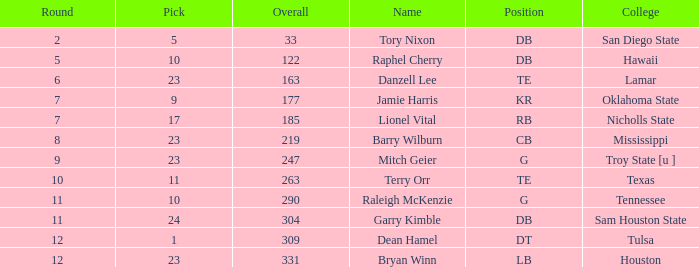How many Picks have a College of hawaii, and an Overall smaller than 122? 0.0. 